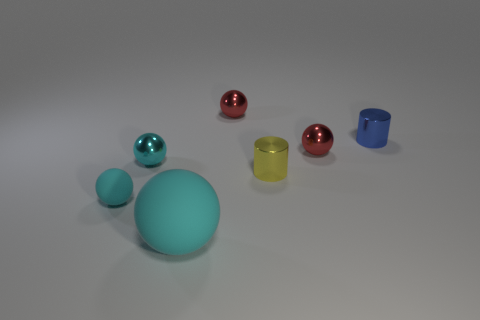There is a tiny cylinder that is on the right side of the tiny yellow thing; what number of cyan shiny things are to the right of it?
Your answer should be very brief. 0. What number of objects are right of the cyan metallic object and in front of the tiny cyan metal sphere?
Provide a succinct answer. 2. What number of objects are either metallic spheres that are behind the blue cylinder or tiny spheres on the left side of the yellow cylinder?
Your response must be concise. 3. How many other objects are the same size as the cyan metallic thing?
Make the answer very short. 5. What shape is the tiny cyan object that is to the right of the cyan rubber sphere that is on the left side of the large matte ball?
Your answer should be compact. Sphere. Do the matte ball left of the cyan shiny sphere and the metal ball on the left side of the big rubber sphere have the same color?
Your answer should be very brief. Yes. Are there any other things that are the same color as the big sphere?
Offer a terse response. Yes. What is the color of the large matte ball?
Your answer should be very brief. Cyan. Is there a matte object?
Make the answer very short. Yes. Are there any small objects in front of the small blue metallic cylinder?
Make the answer very short. Yes. 